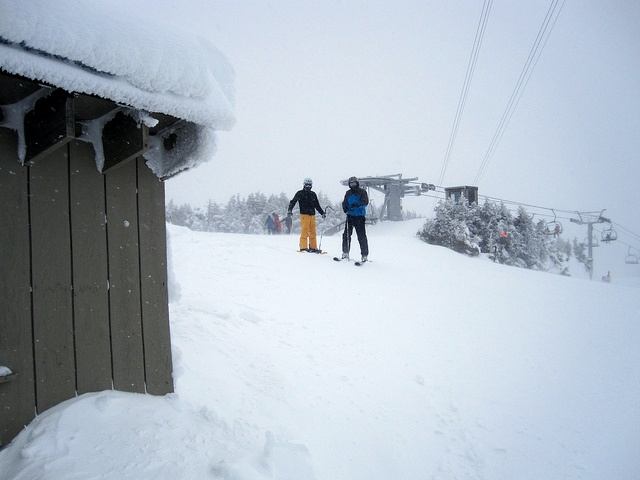Describe the objects in this image and their specific colors. I can see people in darkgray, black, navy, lightgray, and gray tones, people in darkgray, black, tan, and olive tones, people in darkgray and gray tones, people in darkgray and gray tones, and skis in darkgray, lightgray, and gray tones in this image. 